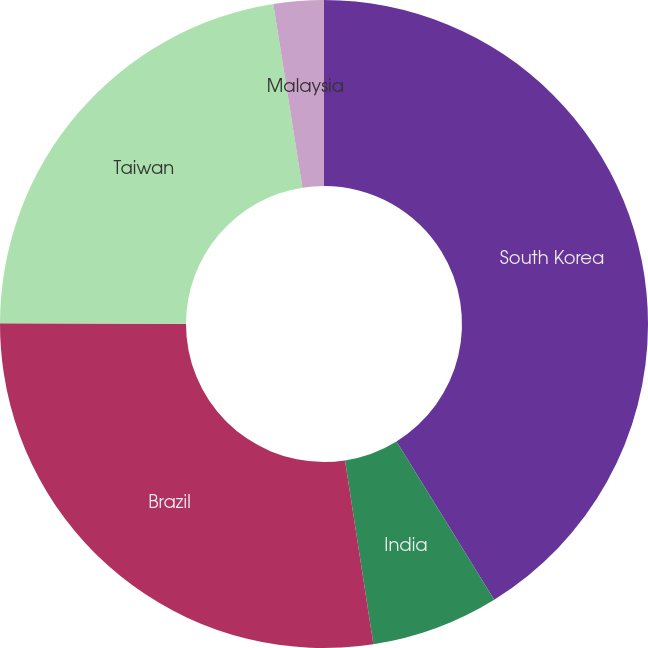Convert chart to OTSL. <chart><loc_0><loc_0><loc_500><loc_500><pie_chart><fcel>South Korea<fcel>India<fcel>Brazil<fcel>Taiwan<fcel>Malaysia<nl><fcel>41.2%<fcel>6.37%<fcel>27.47%<fcel>22.47%<fcel>2.5%<nl></chart> 